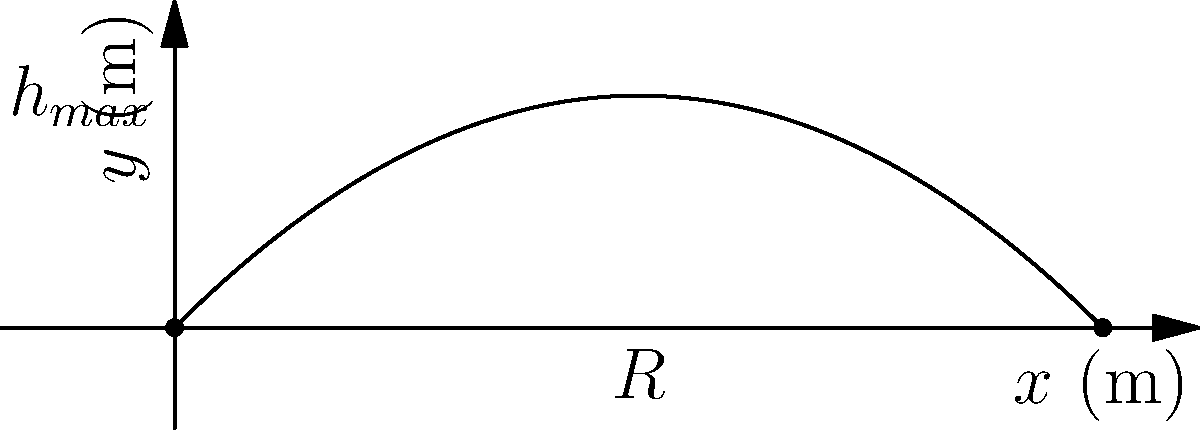A new lab equipment is designed to replace animal testing for studying projectile motion. The device launches a biodegradable sensor at an initial velocity of 20 m/s at an angle of 45° above the horizontal. Assuming air resistance is negligible, what is the maximum height reached by the sensor? How does this height compare to the total horizontal distance traveled? Let's approach this step-by-step:

1) The initial velocity $v_0 = 20$ m/s and the launch angle $\theta = 45°$.

2) The vertical component of the initial velocity is:
   $v_{0y} = v_0 \sin{\theta} = 20 \sin{45°} = 20 \cdot \frac{\sqrt{2}}{2} \approx 14.14$ m/s

3) The time to reach maximum height is when the vertical velocity becomes zero:
   $t_{max} = \frac{v_{0y}}{g} = \frac{14.14}{9.8} \approx 1.44$ s

4) The maximum height is:
   $h_{max} = v_{0y}t_{max} - \frac{1}{2}gt_{max}^2$
   $= 14.14 \cdot 1.44 - \frac{1}{2} \cdot 9.8 \cdot 1.44^2$
   $\approx 20.36 - 10.18 = 10.18$ m

5) The total flight time is twice the time to reach maximum height:
   $t_{total} = 2t_{max} \approx 2.88$ s

6) The horizontal component of velocity is constant:
   $v_x = v_0 \cos{\theta} = 20 \cos{45°} = 20 \cdot \frac{\sqrt{2}}{2} \approx 14.14$ m/s

7) The total horizontal distance (range) is:
   $R = v_x \cdot t_{total} = 14.14 \cdot 2.88 \approx 40.72$ m

8) The ratio of maximum height to range is:
   $\frac{h_{max}}{R} = \frac{10.18}{40.72} = 0.25 = 1:4$
Answer: Maximum height: 10.18 m. Height:Range ratio = 1:4. 